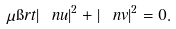Convert formula to latex. <formula><loc_0><loc_0><loc_500><loc_500>\mu \i r t | \ n u | ^ { 2 } + | \ n v | ^ { 2 } = 0 .</formula> 